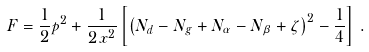Convert formula to latex. <formula><loc_0><loc_0><loc_500><loc_500>F = \frac { 1 } { 2 } p ^ { 2 } + \frac { 1 } { 2 \, x ^ { 2 } } \left [ \left ( N _ { d } - N _ { g } + N _ { \alpha } - N _ { \beta } + \zeta \right ) ^ { 2 } - \frac { 1 } { 4 } \right ] \, .</formula> 